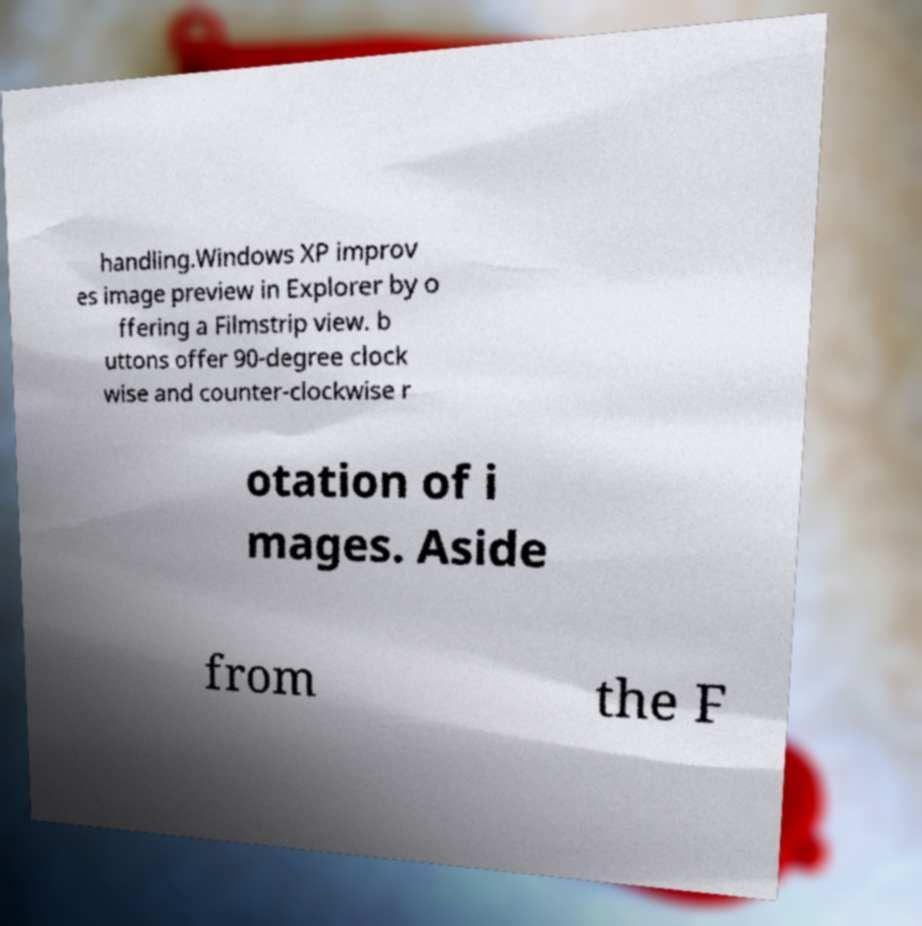There's text embedded in this image that I need extracted. Can you transcribe it verbatim? handling.Windows XP improv es image preview in Explorer by o ffering a Filmstrip view. b uttons offer 90-degree clock wise and counter-clockwise r otation of i mages. Aside from the F 